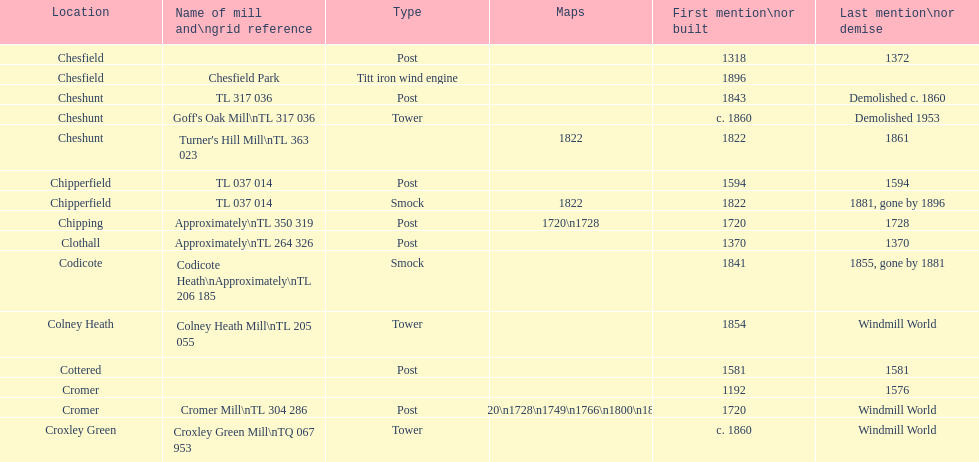What is the quantity of mills initially mentioned or constructed in the 1800s? 8. 